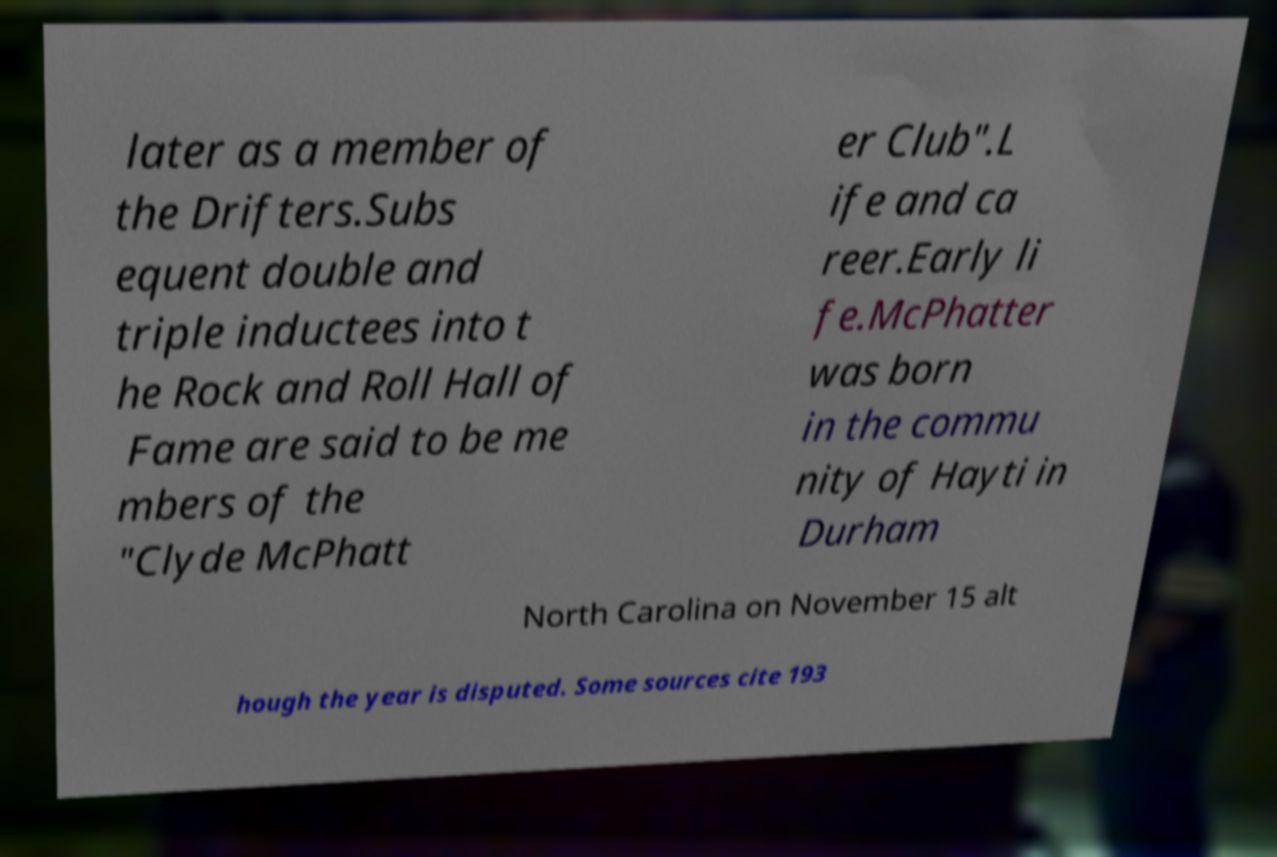Could you extract and type out the text from this image? later as a member of the Drifters.Subs equent double and triple inductees into t he Rock and Roll Hall of Fame are said to be me mbers of the "Clyde McPhatt er Club".L ife and ca reer.Early li fe.McPhatter was born in the commu nity of Hayti in Durham North Carolina on November 15 alt hough the year is disputed. Some sources cite 193 